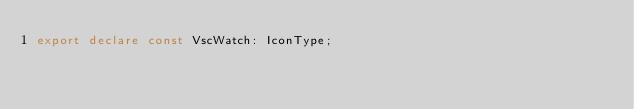<code> <loc_0><loc_0><loc_500><loc_500><_TypeScript_>export declare const VscWatch: IconType;
</code> 